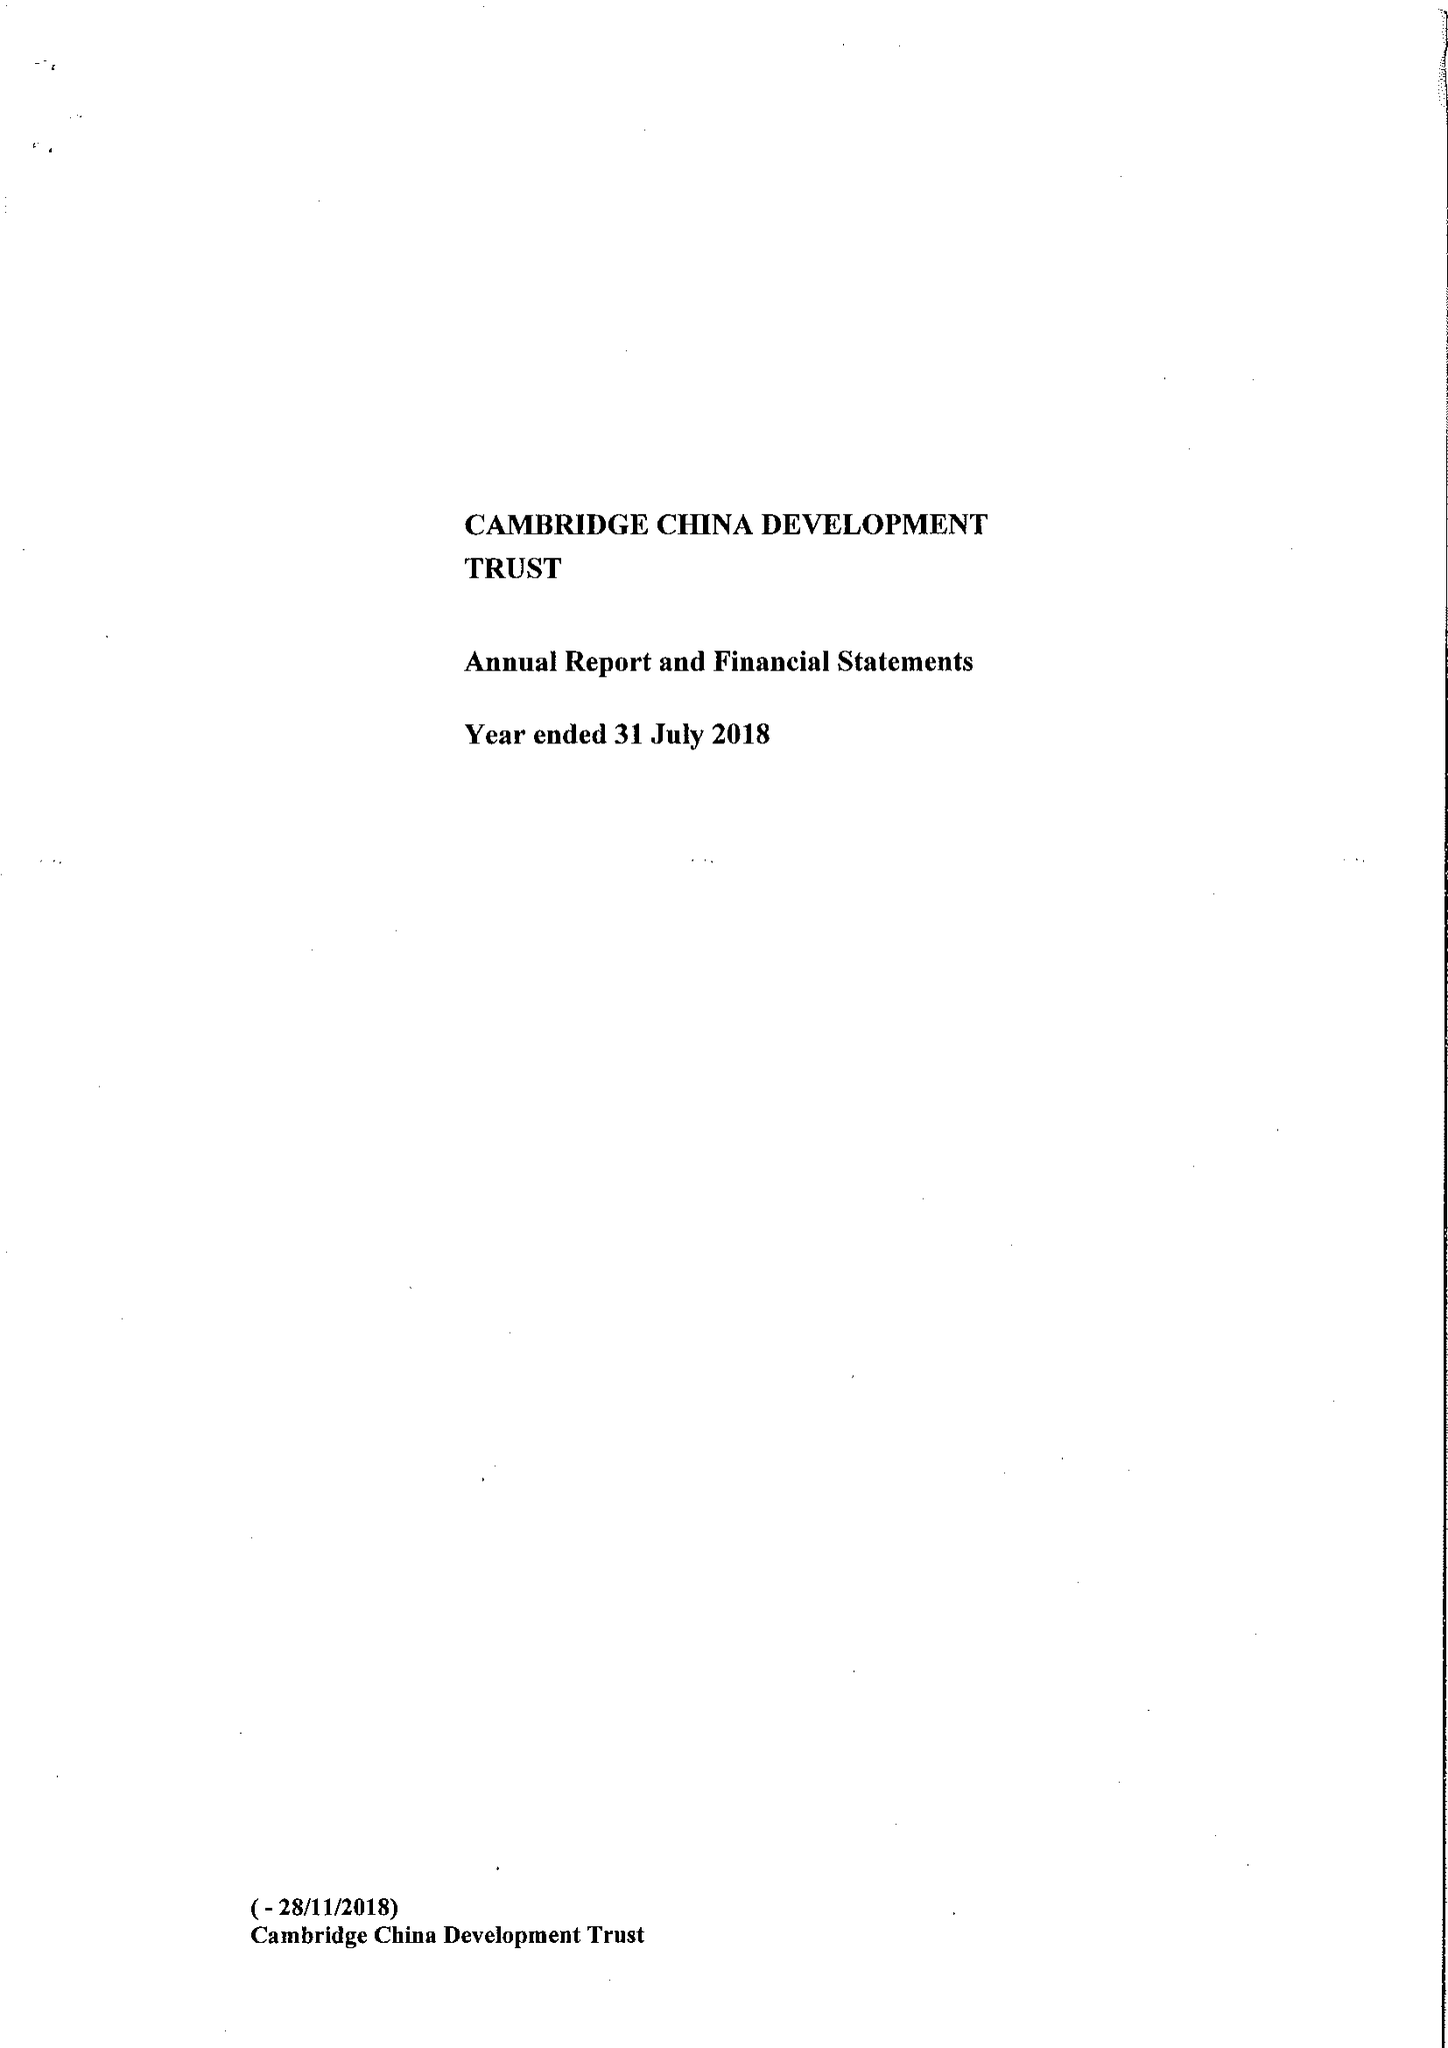What is the value for the address__street_line?
Answer the question using a single word or phrase. None 